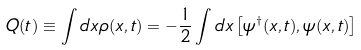<formula> <loc_0><loc_0><loc_500><loc_500>Q ( t ) \equiv \int d x \rho ( x , t ) = - \frac { 1 } { 2 } \int d x \left [ \psi ^ { \dagger } ( x , t ) , \psi ( x , t ) \right ]</formula> 